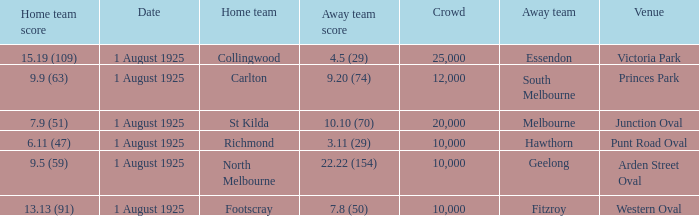Which game with hawthorn as the visiting team had the biggest audience? 10000.0. 